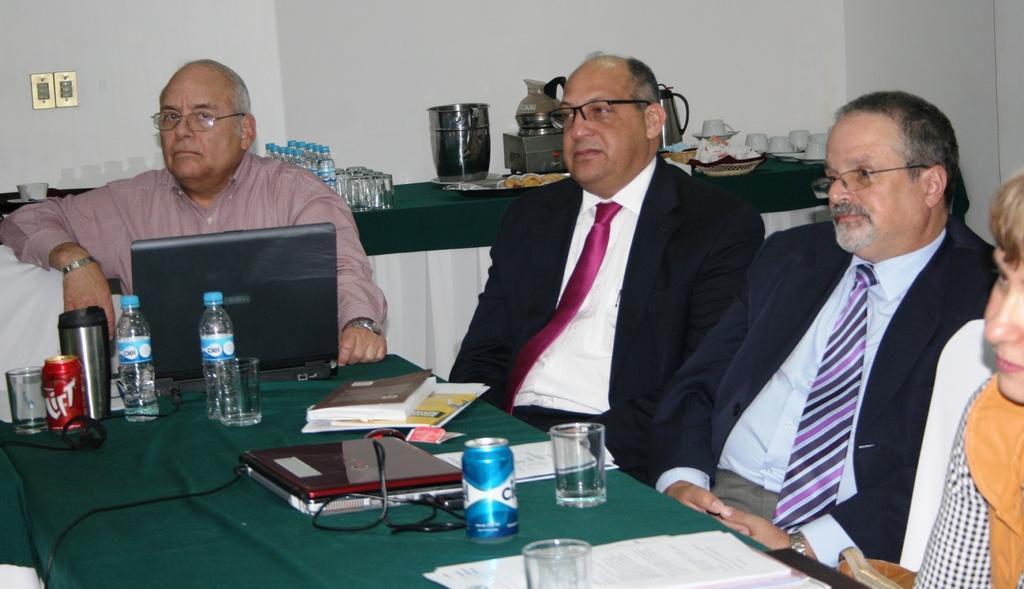Could you give a brief overview of what you see in this image? In this image there are four persons sitting on the chair. On the table there is a glass,laptop,bottle,book. 